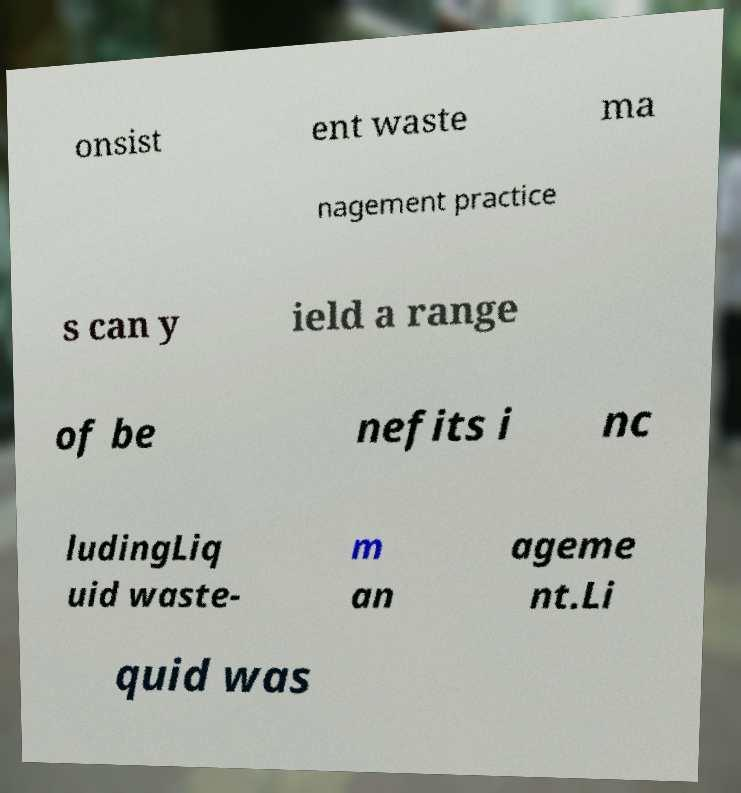Please read and relay the text visible in this image. What does it say? onsist ent waste ma nagement practice s can y ield a range of be nefits i nc ludingLiq uid waste- m an ageme nt.Li quid was 